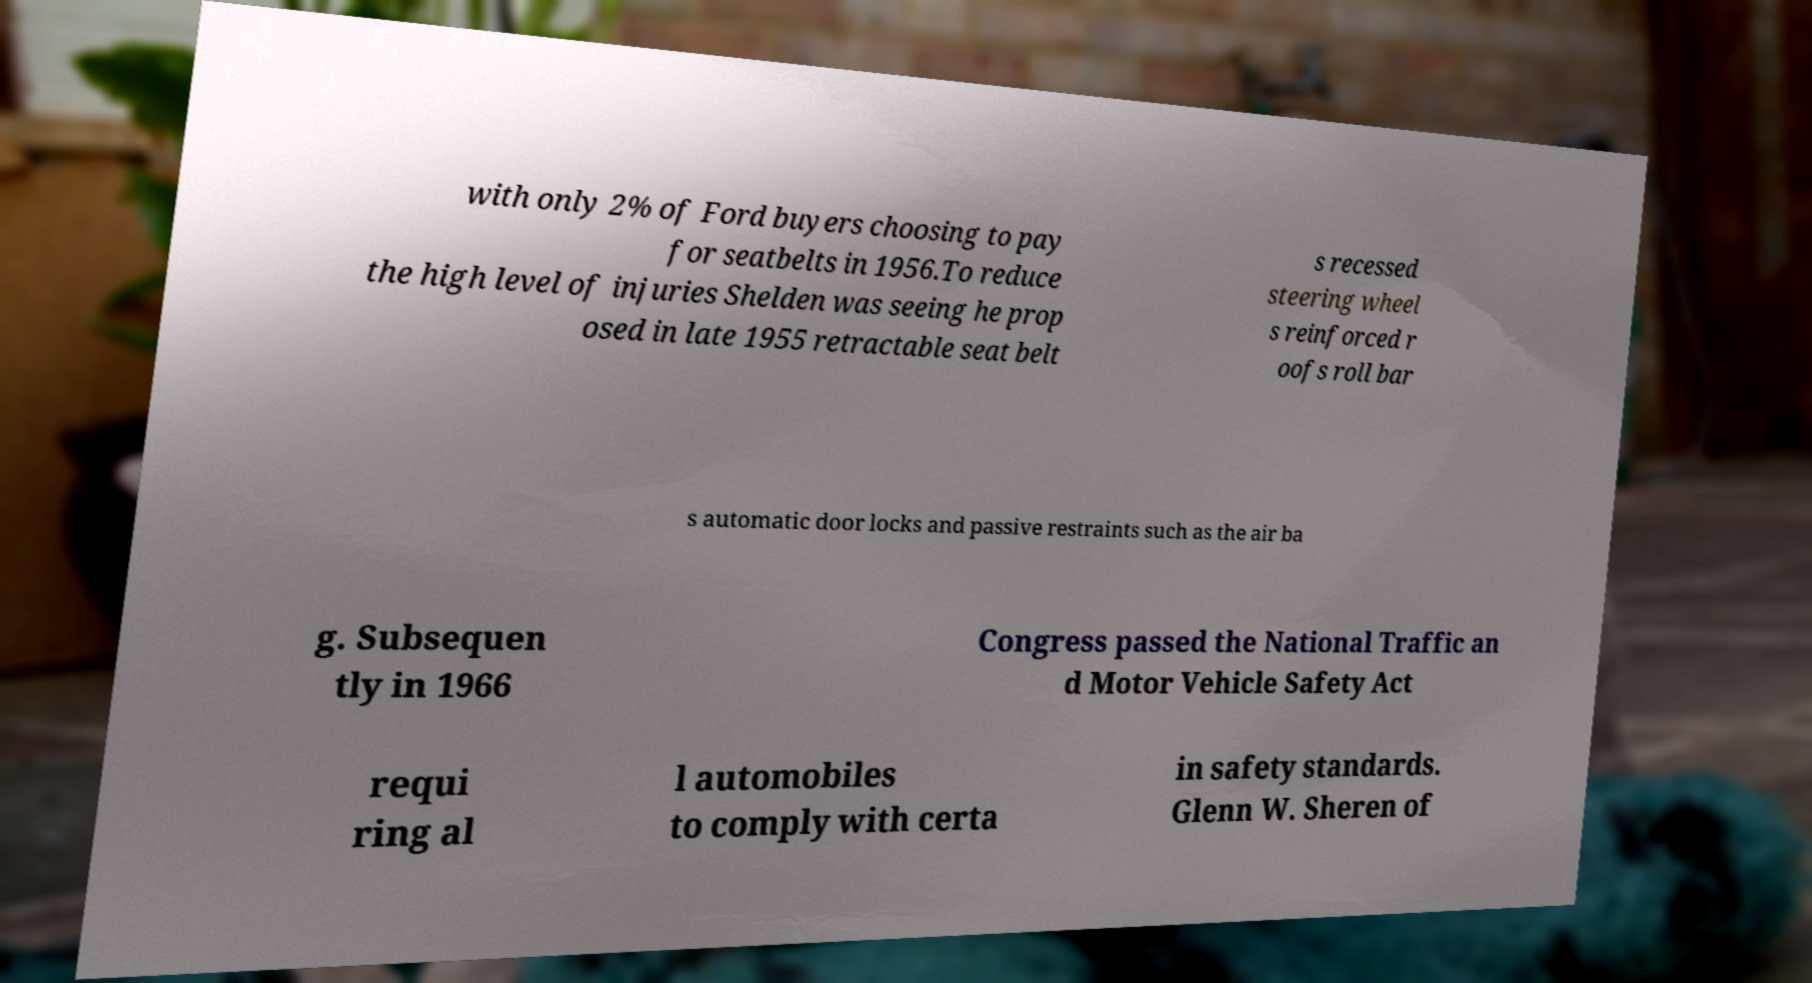For documentation purposes, I need the text within this image transcribed. Could you provide that? with only 2% of Ford buyers choosing to pay for seatbelts in 1956.To reduce the high level of injuries Shelden was seeing he prop osed in late 1955 retractable seat belt s recessed steering wheel s reinforced r oofs roll bar s automatic door locks and passive restraints such as the air ba g. Subsequen tly in 1966 Congress passed the National Traffic an d Motor Vehicle Safety Act requi ring al l automobiles to comply with certa in safety standards. Glenn W. Sheren of 